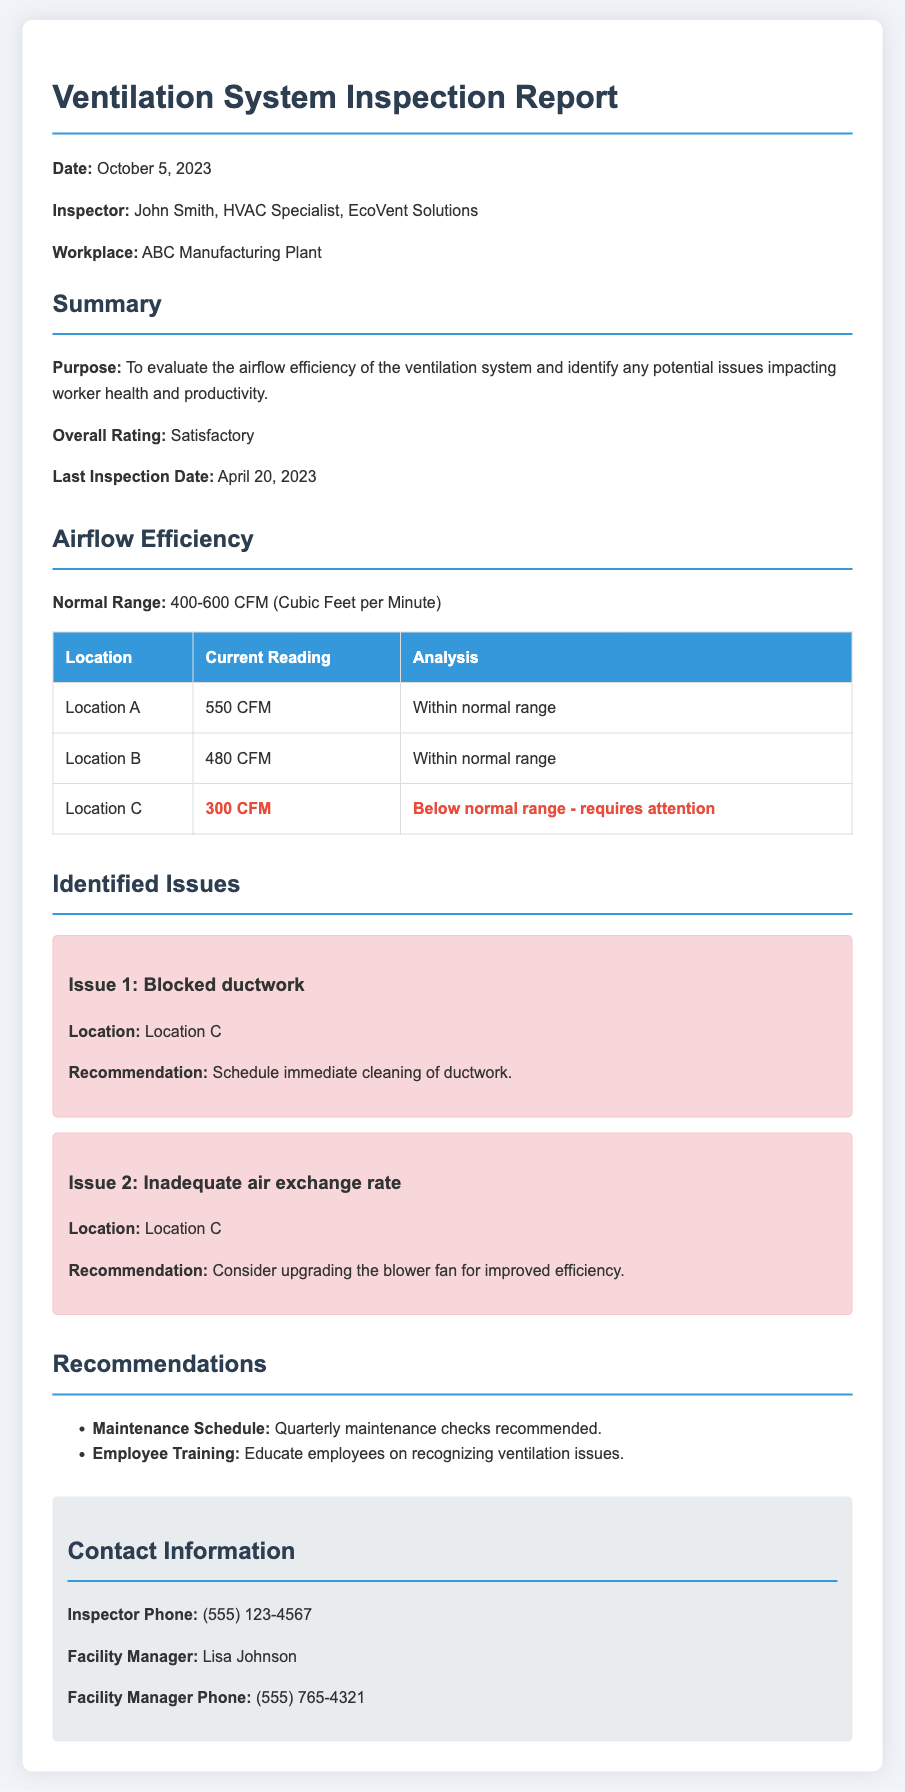What is the date of the inspection? The date of the inspection is mentioned in the introductory section of the report.
Answer: October 5, 2023 Who is the inspector? The name of the inspector is listed in the report along with their title.
Answer: John Smith What is the overall rating of the ventilation system? The overall rating is stated in the summary section of the report.
Answer: Satisfactory What is the current reading for Location C? The current reading for Location C is highlighted in the airflow efficiency table.
Answer: 300 CFM What issue was identified at Location C? The document lists two specific issues related to Location C under the identified issues section.
Answer: Blocked ductwork What is the recommendation for the blocked ductwork issue? The recommendation is provided under the issue details related to blocked ductwork.
Answer: Schedule immediate cleaning of ductwork How often are maintenance checks recommended? The frequency of maintenance checks is stated under the recommendations section.
Answer: Quarterly What air exchange issue was reported for Location C? An issue regarding air exchange at Location C is outlined in the identified issues section.
Answer: Inadequate air exchange rate 